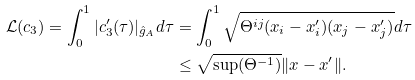<formula> <loc_0><loc_0><loc_500><loc_500>\mathcal { L } ( c _ { 3 } ) = \int _ { 0 } ^ { 1 } | c _ { 3 } ^ { \prime } ( \tau ) | _ { \hat { g } _ { A } } d \tau & = \int _ { 0 } ^ { 1 } \sqrt { \Theta ^ { i j } ( x _ { i } - x ^ { \prime } _ { i } ) ( x _ { j } - x ^ { \prime } _ { j } ) } d \tau \\ & \leq \sqrt { \sup ( \Theta ^ { - 1 } ) } \| x - x ^ { \prime } \| .</formula> 